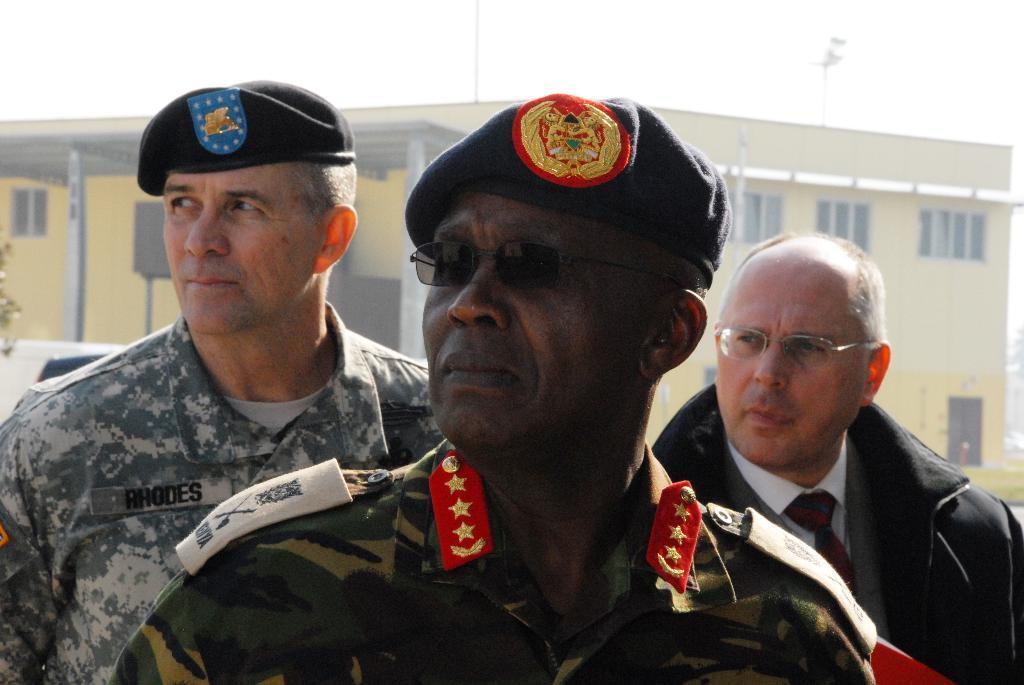How would you summarize this image in a sentence or two? In this picture we can see people and in the background we can see a building. 